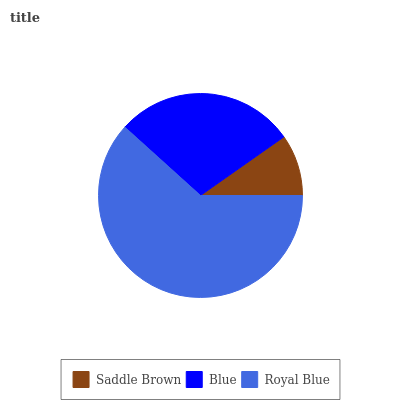Is Saddle Brown the minimum?
Answer yes or no. Yes. Is Royal Blue the maximum?
Answer yes or no. Yes. Is Blue the minimum?
Answer yes or no. No. Is Blue the maximum?
Answer yes or no. No. Is Blue greater than Saddle Brown?
Answer yes or no. Yes. Is Saddle Brown less than Blue?
Answer yes or no. Yes. Is Saddle Brown greater than Blue?
Answer yes or no. No. Is Blue less than Saddle Brown?
Answer yes or no. No. Is Blue the high median?
Answer yes or no. Yes. Is Blue the low median?
Answer yes or no. Yes. Is Royal Blue the high median?
Answer yes or no. No. Is Royal Blue the low median?
Answer yes or no. No. 